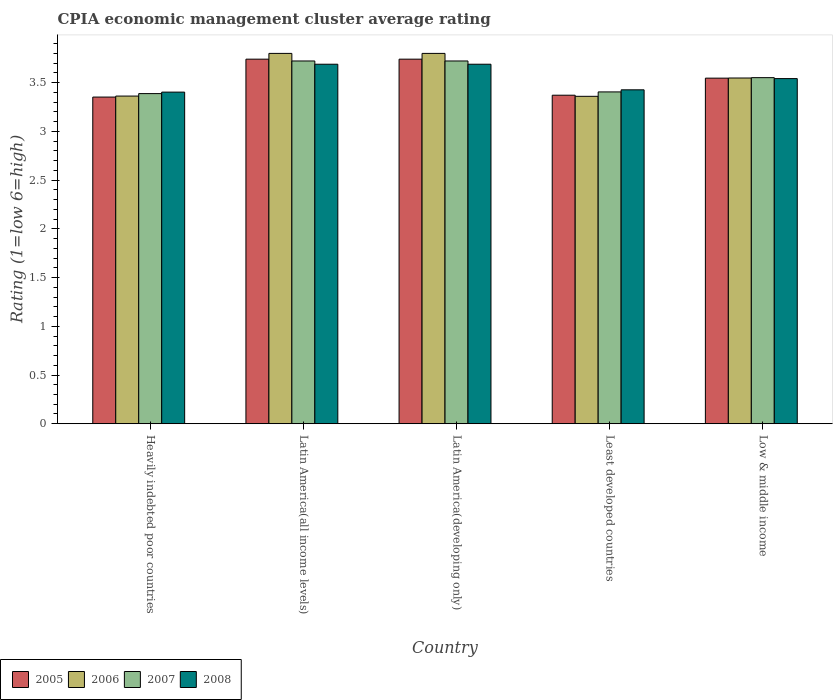How many groups of bars are there?
Your answer should be very brief. 5. How many bars are there on the 2nd tick from the left?
Offer a very short reply. 4. How many bars are there on the 3rd tick from the right?
Provide a short and direct response. 4. What is the label of the 4th group of bars from the left?
Make the answer very short. Least developed countries. What is the CPIA rating in 2006 in Least developed countries?
Provide a short and direct response. 3.36. Across all countries, what is the maximum CPIA rating in 2007?
Offer a terse response. 3.72. Across all countries, what is the minimum CPIA rating in 2006?
Keep it short and to the point. 3.36. In which country was the CPIA rating in 2008 maximum?
Provide a short and direct response. Latin America(all income levels). In which country was the CPIA rating in 2006 minimum?
Offer a terse response. Least developed countries. What is the total CPIA rating in 2006 in the graph?
Your answer should be compact. 17.87. What is the difference between the CPIA rating in 2006 in Latin America(all income levels) and that in Latin America(developing only)?
Your answer should be compact. 0. What is the difference between the CPIA rating in 2005 in Low & middle income and the CPIA rating in 2007 in Heavily indebted poor countries?
Your answer should be compact. 0.16. What is the average CPIA rating in 2005 per country?
Make the answer very short. 3.55. What is the difference between the CPIA rating of/in 2005 and CPIA rating of/in 2006 in Least developed countries?
Provide a succinct answer. 0.01. Is the CPIA rating in 2007 in Heavily indebted poor countries less than that in Low & middle income?
Your answer should be compact. Yes. What is the difference between the highest and the second highest CPIA rating in 2007?
Your answer should be compact. -0.17. What is the difference between the highest and the lowest CPIA rating in 2007?
Offer a terse response. 0.33. Is the sum of the CPIA rating in 2007 in Latin America(developing only) and Least developed countries greater than the maximum CPIA rating in 2008 across all countries?
Ensure brevity in your answer.  Yes. Is it the case that in every country, the sum of the CPIA rating in 2006 and CPIA rating in 2007 is greater than the sum of CPIA rating in 2005 and CPIA rating in 2008?
Ensure brevity in your answer.  No. Is it the case that in every country, the sum of the CPIA rating in 2005 and CPIA rating in 2007 is greater than the CPIA rating in 2006?
Ensure brevity in your answer.  Yes. How many bars are there?
Give a very brief answer. 20. Are all the bars in the graph horizontal?
Your answer should be very brief. No. How many countries are there in the graph?
Your response must be concise. 5. What is the difference between two consecutive major ticks on the Y-axis?
Your answer should be compact. 0.5. Does the graph contain grids?
Your answer should be very brief. No. Where does the legend appear in the graph?
Offer a very short reply. Bottom left. How are the legend labels stacked?
Make the answer very short. Horizontal. What is the title of the graph?
Provide a short and direct response. CPIA economic management cluster average rating. Does "2015" appear as one of the legend labels in the graph?
Offer a terse response. No. What is the label or title of the Y-axis?
Make the answer very short. Rating (1=low 6=high). What is the Rating (1=low 6=high) in 2005 in Heavily indebted poor countries?
Provide a succinct answer. 3.35. What is the Rating (1=low 6=high) in 2006 in Heavily indebted poor countries?
Provide a short and direct response. 3.36. What is the Rating (1=low 6=high) in 2007 in Heavily indebted poor countries?
Offer a terse response. 3.39. What is the Rating (1=low 6=high) of 2008 in Heavily indebted poor countries?
Provide a short and direct response. 3.4. What is the Rating (1=low 6=high) of 2005 in Latin America(all income levels)?
Your answer should be very brief. 3.74. What is the Rating (1=low 6=high) of 2007 in Latin America(all income levels)?
Give a very brief answer. 3.72. What is the Rating (1=low 6=high) in 2008 in Latin America(all income levels)?
Provide a short and direct response. 3.69. What is the Rating (1=low 6=high) of 2005 in Latin America(developing only)?
Your answer should be compact. 3.74. What is the Rating (1=low 6=high) in 2007 in Latin America(developing only)?
Your answer should be very brief. 3.72. What is the Rating (1=low 6=high) in 2008 in Latin America(developing only)?
Make the answer very short. 3.69. What is the Rating (1=low 6=high) of 2005 in Least developed countries?
Provide a short and direct response. 3.37. What is the Rating (1=low 6=high) of 2006 in Least developed countries?
Make the answer very short. 3.36. What is the Rating (1=low 6=high) of 2007 in Least developed countries?
Provide a succinct answer. 3.4. What is the Rating (1=low 6=high) in 2008 in Least developed countries?
Offer a very short reply. 3.43. What is the Rating (1=low 6=high) in 2005 in Low & middle income?
Offer a terse response. 3.55. What is the Rating (1=low 6=high) in 2006 in Low & middle income?
Give a very brief answer. 3.55. What is the Rating (1=low 6=high) in 2007 in Low & middle income?
Make the answer very short. 3.55. What is the Rating (1=low 6=high) of 2008 in Low & middle income?
Make the answer very short. 3.54. Across all countries, what is the maximum Rating (1=low 6=high) in 2005?
Give a very brief answer. 3.74. Across all countries, what is the maximum Rating (1=low 6=high) in 2007?
Provide a short and direct response. 3.72. Across all countries, what is the maximum Rating (1=low 6=high) of 2008?
Your response must be concise. 3.69. Across all countries, what is the minimum Rating (1=low 6=high) of 2005?
Provide a short and direct response. 3.35. Across all countries, what is the minimum Rating (1=low 6=high) in 2006?
Keep it short and to the point. 3.36. Across all countries, what is the minimum Rating (1=low 6=high) in 2007?
Give a very brief answer. 3.39. Across all countries, what is the minimum Rating (1=low 6=high) of 2008?
Offer a very short reply. 3.4. What is the total Rating (1=low 6=high) of 2005 in the graph?
Your response must be concise. 17.75. What is the total Rating (1=low 6=high) in 2006 in the graph?
Your response must be concise. 17.87. What is the total Rating (1=low 6=high) of 2007 in the graph?
Your response must be concise. 17.79. What is the total Rating (1=low 6=high) in 2008 in the graph?
Your answer should be compact. 17.75. What is the difference between the Rating (1=low 6=high) in 2005 in Heavily indebted poor countries and that in Latin America(all income levels)?
Your response must be concise. -0.39. What is the difference between the Rating (1=low 6=high) of 2006 in Heavily indebted poor countries and that in Latin America(all income levels)?
Ensure brevity in your answer.  -0.44. What is the difference between the Rating (1=low 6=high) of 2007 in Heavily indebted poor countries and that in Latin America(all income levels)?
Offer a terse response. -0.33. What is the difference between the Rating (1=low 6=high) in 2008 in Heavily indebted poor countries and that in Latin America(all income levels)?
Keep it short and to the point. -0.29. What is the difference between the Rating (1=low 6=high) of 2005 in Heavily indebted poor countries and that in Latin America(developing only)?
Keep it short and to the point. -0.39. What is the difference between the Rating (1=low 6=high) of 2006 in Heavily indebted poor countries and that in Latin America(developing only)?
Offer a terse response. -0.44. What is the difference between the Rating (1=low 6=high) of 2007 in Heavily indebted poor countries and that in Latin America(developing only)?
Provide a short and direct response. -0.33. What is the difference between the Rating (1=low 6=high) of 2008 in Heavily indebted poor countries and that in Latin America(developing only)?
Your answer should be compact. -0.29. What is the difference between the Rating (1=low 6=high) in 2005 in Heavily indebted poor countries and that in Least developed countries?
Provide a succinct answer. -0.02. What is the difference between the Rating (1=low 6=high) of 2006 in Heavily indebted poor countries and that in Least developed countries?
Give a very brief answer. 0. What is the difference between the Rating (1=low 6=high) of 2007 in Heavily indebted poor countries and that in Least developed countries?
Give a very brief answer. -0.02. What is the difference between the Rating (1=low 6=high) in 2008 in Heavily indebted poor countries and that in Least developed countries?
Offer a terse response. -0.02. What is the difference between the Rating (1=low 6=high) in 2005 in Heavily indebted poor countries and that in Low & middle income?
Offer a very short reply. -0.19. What is the difference between the Rating (1=low 6=high) in 2006 in Heavily indebted poor countries and that in Low & middle income?
Your response must be concise. -0.19. What is the difference between the Rating (1=low 6=high) of 2007 in Heavily indebted poor countries and that in Low & middle income?
Ensure brevity in your answer.  -0.16. What is the difference between the Rating (1=low 6=high) of 2008 in Heavily indebted poor countries and that in Low & middle income?
Provide a succinct answer. -0.14. What is the difference between the Rating (1=low 6=high) of 2006 in Latin America(all income levels) and that in Latin America(developing only)?
Offer a very short reply. 0. What is the difference between the Rating (1=low 6=high) of 2007 in Latin America(all income levels) and that in Latin America(developing only)?
Ensure brevity in your answer.  0. What is the difference between the Rating (1=low 6=high) in 2008 in Latin America(all income levels) and that in Latin America(developing only)?
Provide a succinct answer. 0. What is the difference between the Rating (1=low 6=high) of 2005 in Latin America(all income levels) and that in Least developed countries?
Ensure brevity in your answer.  0.37. What is the difference between the Rating (1=low 6=high) in 2006 in Latin America(all income levels) and that in Least developed countries?
Your answer should be compact. 0.44. What is the difference between the Rating (1=low 6=high) of 2007 in Latin America(all income levels) and that in Least developed countries?
Your response must be concise. 0.32. What is the difference between the Rating (1=low 6=high) in 2008 in Latin America(all income levels) and that in Least developed countries?
Offer a terse response. 0.26. What is the difference between the Rating (1=low 6=high) in 2005 in Latin America(all income levels) and that in Low & middle income?
Your answer should be compact. 0.19. What is the difference between the Rating (1=low 6=high) of 2006 in Latin America(all income levels) and that in Low & middle income?
Give a very brief answer. 0.25. What is the difference between the Rating (1=low 6=high) in 2007 in Latin America(all income levels) and that in Low & middle income?
Your response must be concise. 0.17. What is the difference between the Rating (1=low 6=high) of 2008 in Latin America(all income levels) and that in Low & middle income?
Make the answer very short. 0.15. What is the difference between the Rating (1=low 6=high) of 2005 in Latin America(developing only) and that in Least developed countries?
Ensure brevity in your answer.  0.37. What is the difference between the Rating (1=low 6=high) of 2006 in Latin America(developing only) and that in Least developed countries?
Offer a very short reply. 0.44. What is the difference between the Rating (1=low 6=high) of 2007 in Latin America(developing only) and that in Least developed countries?
Make the answer very short. 0.32. What is the difference between the Rating (1=low 6=high) of 2008 in Latin America(developing only) and that in Least developed countries?
Your answer should be very brief. 0.26. What is the difference between the Rating (1=low 6=high) in 2005 in Latin America(developing only) and that in Low & middle income?
Make the answer very short. 0.19. What is the difference between the Rating (1=low 6=high) of 2006 in Latin America(developing only) and that in Low & middle income?
Make the answer very short. 0.25. What is the difference between the Rating (1=low 6=high) of 2007 in Latin America(developing only) and that in Low & middle income?
Make the answer very short. 0.17. What is the difference between the Rating (1=low 6=high) of 2008 in Latin America(developing only) and that in Low & middle income?
Make the answer very short. 0.15. What is the difference between the Rating (1=low 6=high) of 2005 in Least developed countries and that in Low & middle income?
Ensure brevity in your answer.  -0.18. What is the difference between the Rating (1=low 6=high) in 2006 in Least developed countries and that in Low & middle income?
Make the answer very short. -0.19. What is the difference between the Rating (1=low 6=high) of 2007 in Least developed countries and that in Low & middle income?
Offer a terse response. -0.15. What is the difference between the Rating (1=low 6=high) of 2008 in Least developed countries and that in Low & middle income?
Provide a succinct answer. -0.12. What is the difference between the Rating (1=low 6=high) of 2005 in Heavily indebted poor countries and the Rating (1=low 6=high) of 2006 in Latin America(all income levels)?
Give a very brief answer. -0.45. What is the difference between the Rating (1=low 6=high) in 2005 in Heavily indebted poor countries and the Rating (1=low 6=high) in 2007 in Latin America(all income levels)?
Ensure brevity in your answer.  -0.37. What is the difference between the Rating (1=low 6=high) of 2005 in Heavily indebted poor countries and the Rating (1=low 6=high) of 2008 in Latin America(all income levels)?
Offer a terse response. -0.34. What is the difference between the Rating (1=low 6=high) of 2006 in Heavily indebted poor countries and the Rating (1=low 6=high) of 2007 in Latin America(all income levels)?
Your answer should be compact. -0.36. What is the difference between the Rating (1=low 6=high) in 2006 in Heavily indebted poor countries and the Rating (1=low 6=high) in 2008 in Latin America(all income levels)?
Provide a short and direct response. -0.33. What is the difference between the Rating (1=low 6=high) of 2007 in Heavily indebted poor countries and the Rating (1=low 6=high) of 2008 in Latin America(all income levels)?
Ensure brevity in your answer.  -0.3. What is the difference between the Rating (1=low 6=high) in 2005 in Heavily indebted poor countries and the Rating (1=low 6=high) in 2006 in Latin America(developing only)?
Keep it short and to the point. -0.45. What is the difference between the Rating (1=low 6=high) in 2005 in Heavily indebted poor countries and the Rating (1=low 6=high) in 2007 in Latin America(developing only)?
Provide a short and direct response. -0.37. What is the difference between the Rating (1=low 6=high) in 2005 in Heavily indebted poor countries and the Rating (1=low 6=high) in 2008 in Latin America(developing only)?
Ensure brevity in your answer.  -0.34. What is the difference between the Rating (1=low 6=high) of 2006 in Heavily indebted poor countries and the Rating (1=low 6=high) of 2007 in Latin America(developing only)?
Ensure brevity in your answer.  -0.36. What is the difference between the Rating (1=low 6=high) in 2006 in Heavily indebted poor countries and the Rating (1=low 6=high) in 2008 in Latin America(developing only)?
Provide a short and direct response. -0.33. What is the difference between the Rating (1=low 6=high) of 2007 in Heavily indebted poor countries and the Rating (1=low 6=high) of 2008 in Latin America(developing only)?
Ensure brevity in your answer.  -0.3. What is the difference between the Rating (1=low 6=high) in 2005 in Heavily indebted poor countries and the Rating (1=low 6=high) in 2006 in Least developed countries?
Keep it short and to the point. -0.01. What is the difference between the Rating (1=low 6=high) of 2005 in Heavily indebted poor countries and the Rating (1=low 6=high) of 2007 in Least developed countries?
Your answer should be compact. -0.05. What is the difference between the Rating (1=low 6=high) in 2005 in Heavily indebted poor countries and the Rating (1=low 6=high) in 2008 in Least developed countries?
Provide a succinct answer. -0.07. What is the difference between the Rating (1=low 6=high) in 2006 in Heavily indebted poor countries and the Rating (1=low 6=high) in 2007 in Least developed countries?
Your answer should be compact. -0.04. What is the difference between the Rating (1=low 6=high) in 2006 in Heavily indebted poor countries and the Rating (1=low 6=high) in 2008 in Least developed countries?
Keep it short and to the point. -0.06. What is the difference between the Rating (1=low 6=high) in 2007 in Heavily indebted poor countries and the Rating (1=low 6=high) in 2008 in Least developed countries?
Provide a succinct answer. -0.04. What is the difference between the Rating (1=low 6=high) of 2005 in Heavily indebted poor countries and the Rating (1=low 6=high) of 2006 in Low & middle income?
Your response must be concise. -0.2. What is the difference between the Rating (1=low 6=high) of 2005 in Heavily indebted poor countries and the Rating (1=low 6=high) of 2007 in Low & middle income?
Offer a very short reply. -0.2. What is the difference between the Rating (1=low 6=high) in 2005 in Heavily indebted poor countries and the Rating (1=low 6=high) in 2008 in Low & middle income?
Offer a very short reply. -0.19. What is the difference between the Rating (1=low 6=high) in 2006 in Heavily indebted poor countries and the Rating (1=low 6=high) in 2007 in Low & middle income?
Your answer should be compact. -0.19. What is the difference between the Rating (1=low 6=high) of 2006 in Heavily indebted poor countries and the Rating (1=low 6=high) of 2008 in Low & middle income?
Offer a terse response. -0.18. What is the difference between the Rating (1=low 6=high) in 2007 in Heavily indebted poor countries and the Rating (1=low 6=high) in 2008 in Low & middle income?
Your answer should be compact. -0.15. What is the difference between the Rating (1=low 6=high) in 2005 in Latin America(all income levels) and the Rating (1=low 6=high) in 2006 in Latin America(developing only)?
Your answer should be very brief. -0.06. What is the difference between the Rating (1=low 6=high) of 2005 in Latin America(all income levels) and the Rating (1=low 6=high) of 2007 in Latin America(developing only)?
Your response must be concise. 0.02. What is the difference between the Rating (1=low 6=high) of 2005 in Latin America(all income levels) and the Rating (1=low 6=high) of 2008 in Latin America(developing only)?
Make the answer very short. 0.05. What is the difference between the Rating (1=low 6=high) in 2006 in Latin America(all income levels) and the Rating (1=low 6=high) in 2007 in Latin America(developing only)?
Make the answer very short. 0.08. What is the difference between the Rating (1=low 6=high) in 2005 in Latin America(all income levels) and the Rating (1=low 6=high) in 2006 in Least developed countries?
Ensure brevity in your answer.  0.38. What is the difference between the Rating (1=low 6=high) of 2005 in Latin America(all income levels) and the Rating (1=low 6=high) of 2007 in Least developed countries?
Give a very brief answer. 0.34. What is the difference between the Rating (1=low 6=high) in 2005 in Latin America(all income levels) and the Rating (1=low 6=high) in 2008 in Least developed countries?
Make the answer very short. 0.31. What is the difference between the Rating (1=low 6=high) of 2006 in Latin America(all income levels) and the Rating (1=low 6=high) of 2007 in Least developed countries?
Keep it short and to the point. 0.4. What is the difference between the Rating (1=low 6=high) of 2006 in Latin America(all income levels) and the Rating (1=low 6=high) of 2008 in Least developed countries?
Provide a short and direct response. 0.37. What is the difference between the Rating (1=low 6=high) in 2007 in Latin America(all income levels) and the Rating (1=low 6=high) in 2008 in Least developed countries?
Your answer should be compact. 0.3. What is the difference between the Rating (1=low 6=high) of 2005 in Latin America(all income levels) and the Rating (1=low 6=high) of 2006 in Low & middle income?
Offer a terse response. 0.19. What is the difference between the Rating (1=low 6=high) in 2005 in Latin America(all income levels) and the Rating (1=low 6=high) in 2007 in Low & middle income?
Offer a very short reply. 0.19. What is the difference between the Rating (1=low 6=high) of 2005 in Latin America(all income levels) and the Rating (1=low 6=high) of 2008 in Low & middle income?
Offer a very short reply. 0.2. What is the difference between the Rating (1=low 6=high) in 2006 in Latin America(all income levels) and the Rating (1=low 6=high) in 2007 in Low & middle income?
Give a very brief answer. 0.25. What is the difference between the Rating (1=low 6=high) of 2006 in Latin America(all income levels) and the Rating (1=low 6=high) of 2008 in Low & middle income?
Offer a very short reply. 0.26. What is the difference between the Rating (1=low 6=high) in 2007 in Latin America(all income levels) and the Rating (1=low 6=high) in 2008 in Low & middle income?
Keep it short and to the point. 0.18. What is the difference between the Rating (1=low 6=high) of 2005 in Latin America(developing only) and the Rating (1=low 6=high) of 2006 in Least developed countries?
Keep it short and to the point. 0.38. What is the difference between the Rating (1=low 6=high) in 2005 in Latin America(developing only) and the Rating (1=low 6=high) in 2007 in Least developed countries?
Give a very brief answer. 0.34. What is the difference between the Rating (1=low 6=high) in 2005 in Latin America(developing only) and the Rating (1=low 6=high) in 2008 in Least developed countries?
Provide a succinct answer. 0.31. What is the difference between the Rating (1=low 6=high) in 2006 in Latin America(developing only) and the Rating (1=low 6=high) in 2007 in Least developed countries?
Provide a succinct answer. 0.4. What is the difference between the Rating (1=low 6=high) in 2006 in Latin America(developing only) and the Rating (1=low 6=high) in 2008 in Least developed countries?
Offer a terse response. 0.37. What is the difference between the Rating (1=low 6=high) of 2007 in Latin America(developing only) and the Rating (1=low 6=high) of 2008 in Least developed countries?
Offer a very short reply. 0.3. What is the difference between the Rating (1=low 6=high) of 2005 in Latin America(developing only) and the Rating (1=low 6=high) of 2006 in Low & middle income?
Offer a very short reply. 0.19. What is the difference between the Rating (1=low 6=high) in 2005 in Latin America(developing only) and the Rating (1=low 6=high) in 2007 in Low & middle income?
Your answer should be compact. 0.19. What is the difference between the Rating (1=low 6=high) in 2005 in Latin America(developing only) and the Rating (1=low 6=high) in 2008 in Low & middle income?
Offer a terse response. 0.2. What is the difference between the Rating (1=low 6=high) of 2006 in Latin America(developing only) and the Rating (1=low 6=high) of 2007 in Low & middle income?
Keep it short and to the point. 0.25. What is the difference between the Rating (1=low 6=high) of 2006 in Latin America(developing only) and the Rating (1=low 6=high) of 2008 in Low & middle income?
Your answer should be compact. 0.26. What is the difference between the Rating (1=low 6=high) of 2007 in Latin America(developing only) and the Rating (1=low 6=high) of 2008 in Low & middle income?
Offer a terse response. 0.18. What is the difference between the Rating (1=low 6=high) in 2005 in Least developed countries and the Rating (1=low 6=high) in 2006 in Low & middle income?
Make the answer very short. -0.18. What is the difference between the Rating (1=low 6=high) of 2005 in Least developed countries and the Rating (1=low 6=high) of 2007 in Low & middle income?
Offer a very short reply. -0.18. What is the difference between the Rating (1=low 6=high) in 2005 in Least developed countries and the Rating (1=low 6=high) in 2008 in Low & middle income?
Keep it short and to the point. -0.17. What is the difference between the Rating (1=low 6=high) in 2006 in Least developed countries and the Rating (1=low 6=high) in 2007 in Low & middle income?
Offer a very short reply. -0.19. What is the difference between the Rating (1=low 6=high) of 2006 in Least developed countries and the Rating (1=low 6=high) of 2008 in Low & middle income?
Offer a terse response. -0.18. What is the difference between the Rating (1=low 6=high) of 2007 in Least developed countries and the Rating (1=low 6=high) of 2008 in Low & middle income?
Give a very brief answer. -0.14. What is the average Rating (1=low 6=high) in 2005 per country?
Give a very brief answer. 3.55. What is the average Rating (1=low 6=high) of 2006 per country?
Keep it short and to the point. 3.57. What is the average Rating (1=low 6=high) of 2007 per country?
Provide a succinct answer. 3.56. What is the average Rating (1=low 6=high) in 2008 per country?
Make the answer very short. 3.55. What is the difference between the Rating (1=low 6=high) in 2005 and Rating (1=low 6=high) in 2006 in Heavily indebted poor countries?
Your answer should be compact. -0.01. What is the difference between the Rating (1=low 6=high) of 2005 and Rating (1=low 6=high) of 2007 in Heavily indebted poor countries?
Ensure brevity in your answer.  -0.04. What is the difference between the Rating (1=low 6=high) of 2005 and Rating (1=low 6=high) of 2008 in Heavily indebted poor countries?
Your answer should be very brief. -0.05. What is the difference between the Rating (1=low 6=high) of 2006 and Rating (1=low 6=high) of 2007 in Heavily indebted poor countries?
Keep it short and to the point. -0.03. What is the difference between the Rating (1=low 6=high) of 2006 and Rating (1=low 6=high) of 2008 in Heavily indebted poor countries?
Your response must be concise. -0.04. What is the difference between the Rating (1=low 6=high) of 2007 and Rating (1=low 6=high) of 2008 in Heavily indebted poor countries?
Provide a short and direct response. -0.02. What is the difference between the Rating (1=low 6=high) of 2005 and Rating (1=low 6=high) of 2006 in Latin America(all income levels)?
Provide a succinct answer. -0.06. What is the difference between the Rating (1=low 6=high) in 2005 and Rating (1=low 6=high) in 2007 in Latin America(all income levels)?
Offer a very short reply. 0.02. What is the difference between the Rating (1=low 6=high) of 2005 and Rating (1=low 6=high) of 2008 in Latin America(all income levels)?
Your answer should be very brief. 0.05. What is the difference between the Rating (1=low 6=high) of 2006 and Rating (1=low 6=high) of 2007 in Latin America(all income levels)?
Offer a very short reply. 0.08. What is the difference between the Rating (1=low 6=high) of 2006 and Rating (1=low 6=high) of 2008 in Latin America(all income levels)?
Make the answer very short. 0.11. What is the difference between the Rating (1=low 6=high) in 2007 and Rating (1=low 6=high) in 2008 in Latin America(all income levels)?
Ensure brevity in your answer.  0.03. What is the difference between the Rating (1=low 6=high) in 2005 and Rating (1=low 6=high) in 2006 in Latin America(developing only)?
Make the answer very short. -0.06. What is the difference between the Rating (1=low 6=high) in 2005 and Rating (1=low 6=high) in 2007 in Latin America(developing only)?
Your answer should be very brief. 0.02. What is the difference between the Rating (1=low 6=high) of 2005 and Rating (1=low 6=high) of 2008 in Latin America(developing only)?
Offer a very short reply. 0.05. What is the difference between the Rating (1=low 6=high) of 2006 and Rating (1=low 6=high) of 2007 in Latin America(developing only)?
Ensure brevity in your answer.  0.08. What is the difference between the Rating (1=low 6=high) in 2006 and Rating (1=low 6=high) in 2008 in Latin America(developing only)?
Give a very brief answer. 0.11. What is the difference between the Rating (1=low 6=high) in 2005 and Rating (1=low 6=high) in 2006 in Least developed countries?
Ensure brevity in your answer.  0.01. What is the difference between the Rating (1=low 6=high) of 2005 and Rating (1=low 6=high) of 2007 in Least developed countries?
Your answer should be very brief. -0.03. What is the difference between the Rating (1=low 6=high) of 2005 and Rating (1=low 6=high) of 2008 in Least developed countries?
Give a very brief answer. -0.06. What is the difference between the Rating (1=low 6=high) of 2006 and Rating (1=low 6=high) of 2007 in Least developed countries?
Offer a terse response. -0.05. What is the difference between the Rating (1=low 6=high) in 2006 and Rating (1=low 6=high) in 2008 in Least developed countries?
Make the answer very short. -0.07. What is the difference between the Rating (1=low 6=high) of 2007 and Rating (1=low 6=high) of 2008 in Least developed countries?
Your answer should be very brief. -0.02. What is the difference between the Rating (1=low 6=high) of 2005 and Rating (1=low 6=high) of 2006 in Low & middle income?
Provide a short and direct response. -0. What is the difference between the Rating (1=low 6=high) in 2005 and Rating (1=low 6=high) in 2007 in Low & middle income?
Your answer should be very brief. -0.01. What is the difference between the Rating (1=low 6=high) in 2005 and Rating (1=low 6=high) in 2008 in Low & middle income?
Keep it short and to the point. 0. What is the difference between the Rating (1=low 6=high) in 2006 and Rating (1=low 6=high) in 2007 in Low & middle income?
Keep it short and to the point. -0. What is the difference between the Rating (1=low 6=high) in 2006 and Rating (1=low 6=high) in 2008 in Low & middle income?
Ensure brevity in your answer.  0.01. What is the difference between the Rating (1=low 6=high) in 2007 and Rating (1=low 6=high) in 2008 in Low & middle income?
Your response must be concise. 0.01. What is the ratio of the Rating (1=low 6=high) of 2005 in Heavily indebted poor countries to that in Latin America(all income levels)?
Your answer should be compact. 0.9. What is the ratio of the Rating (1=low 6=high) in 2006 in Heavily indebted poor countries to that in Latin America(all income levels)?
Keep it short and to the point. 0.88. What is the ratio of the Rating (1=low 6=high) in 2007 in Heavily indebted poor countries to that in Latin America(all income levels)?
Offer a terse response. 0.91. What is the ratio of the Rating (1=low 6=high) of 2008 in Heavily indebted poor countries to that in Latin America(all income levels)?
Keep it short and to the point. 0.92. What is the ratio of the Rating (1=low 6=high) in 2005 in Heavily indebted poor countries to that in Latin America(developing only)?
Your answer should be very brief. 0.9. What is the ratio of the Rating (1=low 6=high) in 2006 in Heavily indebted poor countries to that in Latin America(developing only)?
Your answer should be compact. 0.88. What is the ratio of the Rating (1=low 6=high) in 2007 in Heavily indebted poor countries to that in Latin America(developing only)?
Give a very brief answer. 0.91. What is the ratio of the Rating (1=low 6=high) of 2008 in Heavily indebted poor countries to that in Latin America(developing only)?
Give a very brief answer. 0.92. What is the ratio of the Rating (1=low 6=high) of 2006 in Heavily indebted poor countries to that in Least developed countries?
Offer a very short reply. 1. What is the ratio of the Rating (1=low 6=high) of 2007 in Heavily indebted poor countries to that in Least developed countries?
Your answer should be compact. 0.99. What is the ratio of the Rating (1=low 6=high) of 2005 in Heavily indebted poor countries to that in Low & middle income?
Your response must be concise. 0.95. What is the ratio of the Rating (1=low 6=high) in 2006 in Heavily indebted poor countries to that in Low & middle income?
Make the answer very short. 0.95. What is the ratio of the Rating (1=low 6=high) of 2007 in Heavily indebted poor countries to that in Low & middle income?
Your answer should be compact. 0.95. What is the ratio of the Rating (1=low 6=high) in 2008 in Heavily indebted poor countries to that in Low & middle income?
Ensure brevity in your answer.  0.96. What is the ratio of the Rating (1=low 6=high) in 2008 in Latin America(all income levels) to that in Latin America(developing only)?
Offer a very short reply. 1. What is the ratio of the Rating (1=low 6=high) of 2005 in Latin America(all income levels) to that in Least developed countries?
Offer a terse response. 1.11. What is the ratio of the Rating (1=low 6=high) in 2006 in Latin America(all income levels) to that in Least developed countries?
Offer a very short reply. 1.13. What is the ratio of the Rating (1=low 6=high) in 2007 in Latin America(all income levels) to that in Least developed countries?
Keep it short and to the point. 1.09. What is the ratio of the Rating (1=low 6=high) in 2008 in Latin America(all income levels) to that in Least developed countries?
Make the answer very short. 1.08. What is the ratio of the Rating (1=low 6=high) in 2005 in Latin America(all income levels) to that in Low & middle income?
Your answer should be compact. 1.05. What is the ratio of the Rating (1=low 6=high) of 2006 in Latin America(all income levels) to that in Low & middle income?
Offer a terse response. 1.07. What is the ratio of the Rating (1=low 6=high) in 2007 in Latin America(all income levels) to that in Low & middle income?
Keep it short and to the point. 1.05. What is the ratio of the Rating (1=low 6=high) of 2008 in Latin America(all income levels) to that in Low & middle income?
Offer a very short reply. 1.04. What is the ratio of the Rating (1=low 6=high) of 2005 in Latin America(developing only) to that in Least developed countries?
Offer a terse response. 1.11. What is the ratio of the Rating (1=low 6=high) in 2006 in Latin America(developing only) to that in Least developed countries?
Your answer should be very brief. 1.13. What is the ratio of the Rating (1=low 6=high) of 2007 in Latin America(developing only) to that in Least developed countries?
Ensure brevity in your answer.  1.09. What is the ratio of the Rating (1=low 6=high) in 2008 in Latin America(developing only) to that in Least developed countries?
Make the answer very short. 1.08. What is the ratio of the Rating (1=low 6=high) of 2005 in Latin America(developing only) to that in Low & middle income?
Your answer should be compact. 1.05. What is the ratio of the Rating (1=low 6=high) of 2006 in Latin America(developing only) to that in Low & middle income?
Your answer should be compact. 1.07. What is the ratio of the Rating (1=low 6=high) of 2007 in Latin America(developing only) to that in Low & middle income?
Provide a short and direct response. 1.05. What is the ratio of the Rating (1=low 6=high) in 2008 in Latin America(developing only) to that in Low & middle income?
Ensure brevity in your answer.  1.04. What is the ratio of the Rating (1=low 6=high) of 2005 in Least developed countries to that in Low & middle income?
Offer a terse response. 0.95. What is the ratio of the Rating (1=low 6=high) of 2006 in Least developed countries to that in Low & middle income?
Offer a very short reply. 0.95. What is the ratio of the Rating (1=low 6=high) in 2007 in Least developed countries to that in Low & middle income?
Offer a terse response. 0.96. What is the ratio of the Rating (1=low 6=high) in 2008 in Least developed countries to that in Low & middle income?
Your answer should be compact. 0.97. What is the difference between the highest and the lowest Rating (1=low 6=high) of 2005?
Give a very brief answer. 0.39. What is the difference between the highest and the lowest Rating (1=low 6=high) of 2006?
Your response must be concise. 0.44. What is the difference between the highest and the lowest Rating (1=low 6=high) of 2007?
Give a very brief answer. 0.33. What is the difference between the highest and the lowest Rating (1=low 6=high) of 2008?
Make the answer very short. 0.29. 